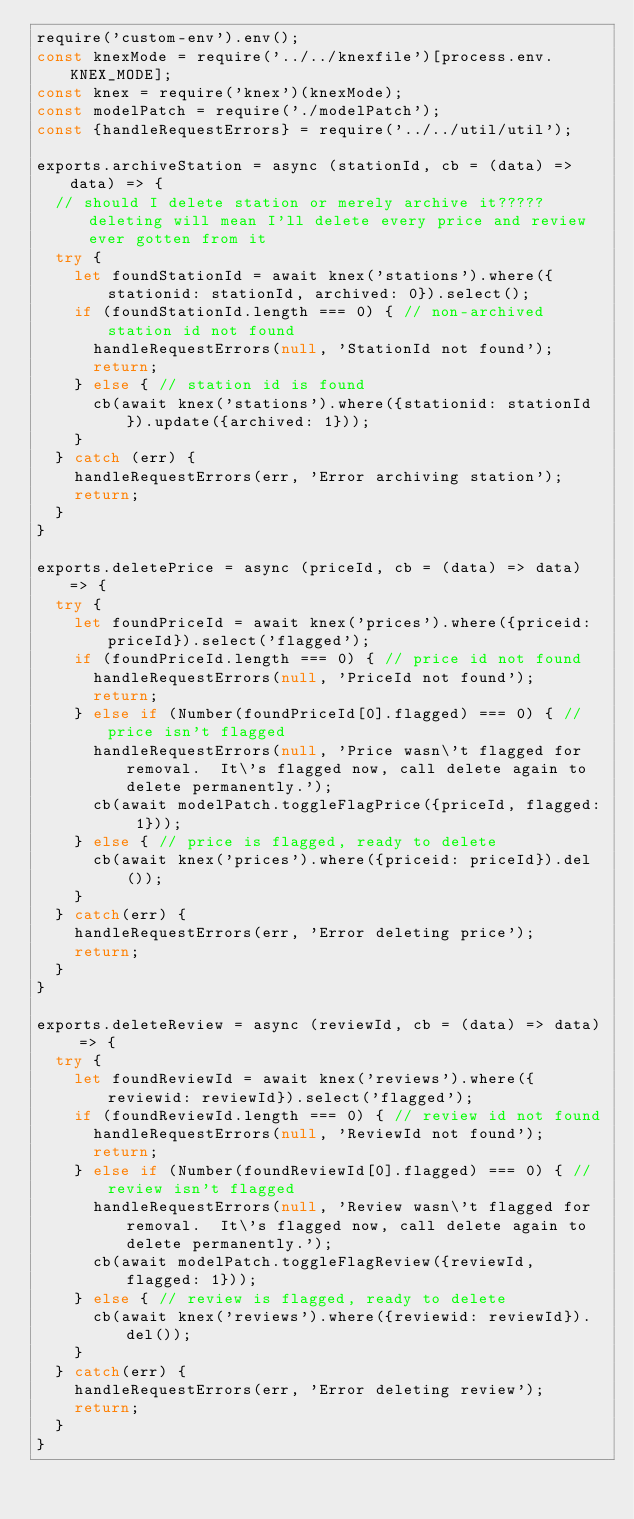Convert code to text. <code><loc_0><loc_0><loc_500><loc_500><_JavaScript_>require('custom-env').env();
const knexMode = require('../../knexfile')[process.env.KNEX_MODE];
const knex = require('knex')(knexMode);
const modelPatch = require('./modelPatch');
const {handleRequestErrors} = require('../../util/util');

exports.archiveStation = async (stationId, cb = (data) => data) => {
  // should I delete station or merely archive it?????  deleting will mean I'll delete every price and review ever gotten from it
  try {
    let foundStationId = await knex('stations').where({stationid: stationId, archived: 0}).select();
    if (foundStationId.length === 0) { // non-archived station id not found
      handleRequestErrors(null, 'StationId not found');
      return;
    } else { // station id is found
      cb(await knex('stations').where({stationid: stationId}).update({archived: 1}));
    }
  } catch (err) {
    handleRequestErrors(err, 'Error archiving station');
    return;
  }
}

exports.deletePrice = async (priceId, cb = (data) => data) => {
  try {
    let foundPriceId = await knex('prices').where({priceid: priceId}).select('flagged');
    if (foundPriceId.length === 0) { // price id not found
      handleRequestErrors(null, 'PriceId not found');
      return;
    } else if (Number(foundPriceId[0].flagged) === 0) { // price isn't flagged
      handleRequestErrors(null, 'Price wasn\'t flagged for removal.  It\'s flagged now, call delete again to delete permanently.');
      cb(await modelPatch.toggleFlagPrice({priceId, flagged: 1}));
    } else { // price is flagged, ready to delete
      cb(await knex('prices').where({priceid: priceId}).del());
    }
  } catch(err) {
    handleRequestErrors(err, 'Error deleting price');
    return;
  }
} 

exports.deleteReview = async (reviewId, cb = (data) => data) => {
  try {
    let foundReviewId = await knex('reviews').where({reviewid: reviewId}).select('flagged');
    if (foundReviewId.length === 0) { // review id not found
      handleRequestErrors(null, 'ReviewId not found');
      return;
    } else if (Number(foundReviewId[0].flagged) === 0) { // review isn't flagged
      handleRequestErrors(null, 'Review wasn\'t flagged for removal.  It\'s flagged now, call delete again to delete permanently.');
      cb(await modelPatch.toggleFlagReview({reviewId, flagged: 1}));
    } else { // review is flagged, ready to delete
      cb(await knex('reviews').where({reviewid: reviewId}).del());
    }
  } catch(err) {
    handleRequestErrors(err, 'Error deleting review');
    return;
  }
}</code> 